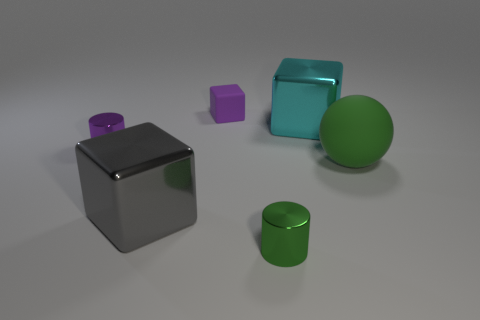How many other big shiny things are the same shape as the big green thing?
Keep it short and to the point. 0. What is the small green cylinder made of?
Offer a very short reply. Metal. Is the shape of the small green metallic object the same as the tiny purple shiny object?
Provide a succinct answer. Yes. Is there a thing made of the same material as the big sphere?
Give a very brief answer. Yes. There is a small object that is both in front of the big cyan object and behind the big rubber sphere; what color is it?
Ensure brevity in your answer.  Purple. There is a big object behind the green matte object; what is it made of?
Offer a terse response. Metal. Is there another gray thing of the same shape as the small matte thing?
Keep it short and to the point. Yes. What number of other objects are the same shape as the big rubber object?
Offer a terse response. 0. There is a tiny green object; does it have the same shape as the small purple object on the right side of the purple cylinder?
Make the answer very short. No. There is a small purple thing that is the same shape as the big gray thing; what material is it?
Your answer should be compact. Rubber. 